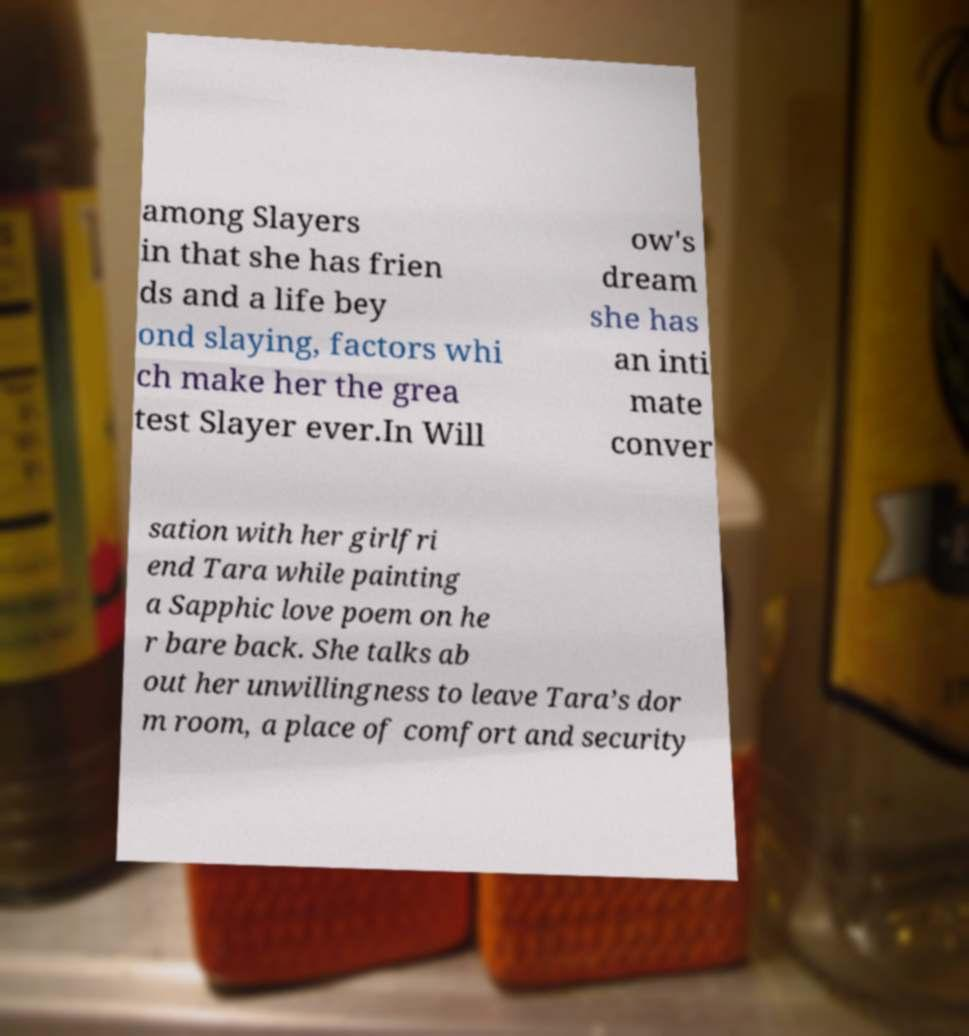I need the written content from this picture converted into text. Can you do that? among Slayers in that she has frien ds and a life bey ond slaying, factors whi ch make her the grea test Slayer ever.In Will ow's dream she has an inti mate conver sation with her girlfri end Tara while painting a Sapphic love poem on he r bare back. She talks ab out her unwillingness to leave Tara’s dor m room, a place of comfort and security 